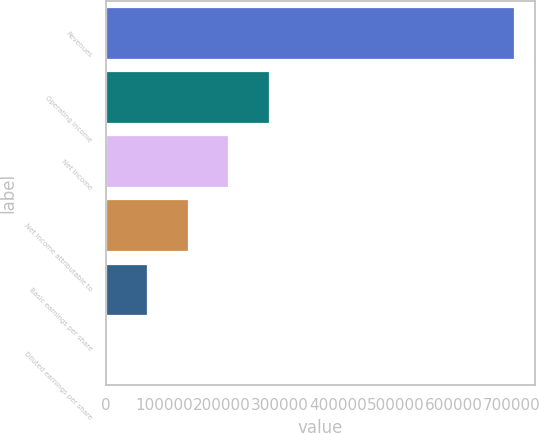<chart> <loc_0><loc_0><loc_500><loc_500><bar_chart><fcel>Revenues<fcel>Operating income<fcel>Net income<fcel>Net income attributable to<fcel>Basic earnings per share<fcel>Diluted earnings per share<nl><fcel>704895<fcel>281959<fcel>211469<fcel>140980<fcel>70490.5<fcel>1.1<nl></chart> 